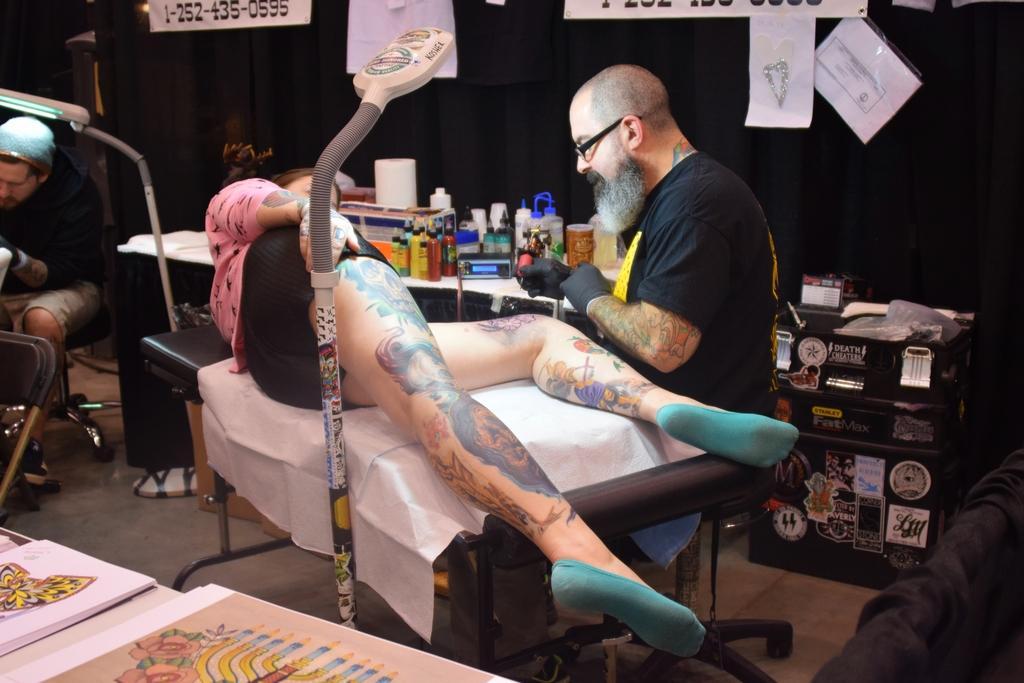Could you give a brief overview of what you see in this image? This picture shows a man piercing a tattoo on a woman's leg in a tattoo store 